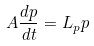<formula> <loc_0><loc_0><loc_500><loc_500>A \frac { d p } { d t } = L _ { p } p</formula> 